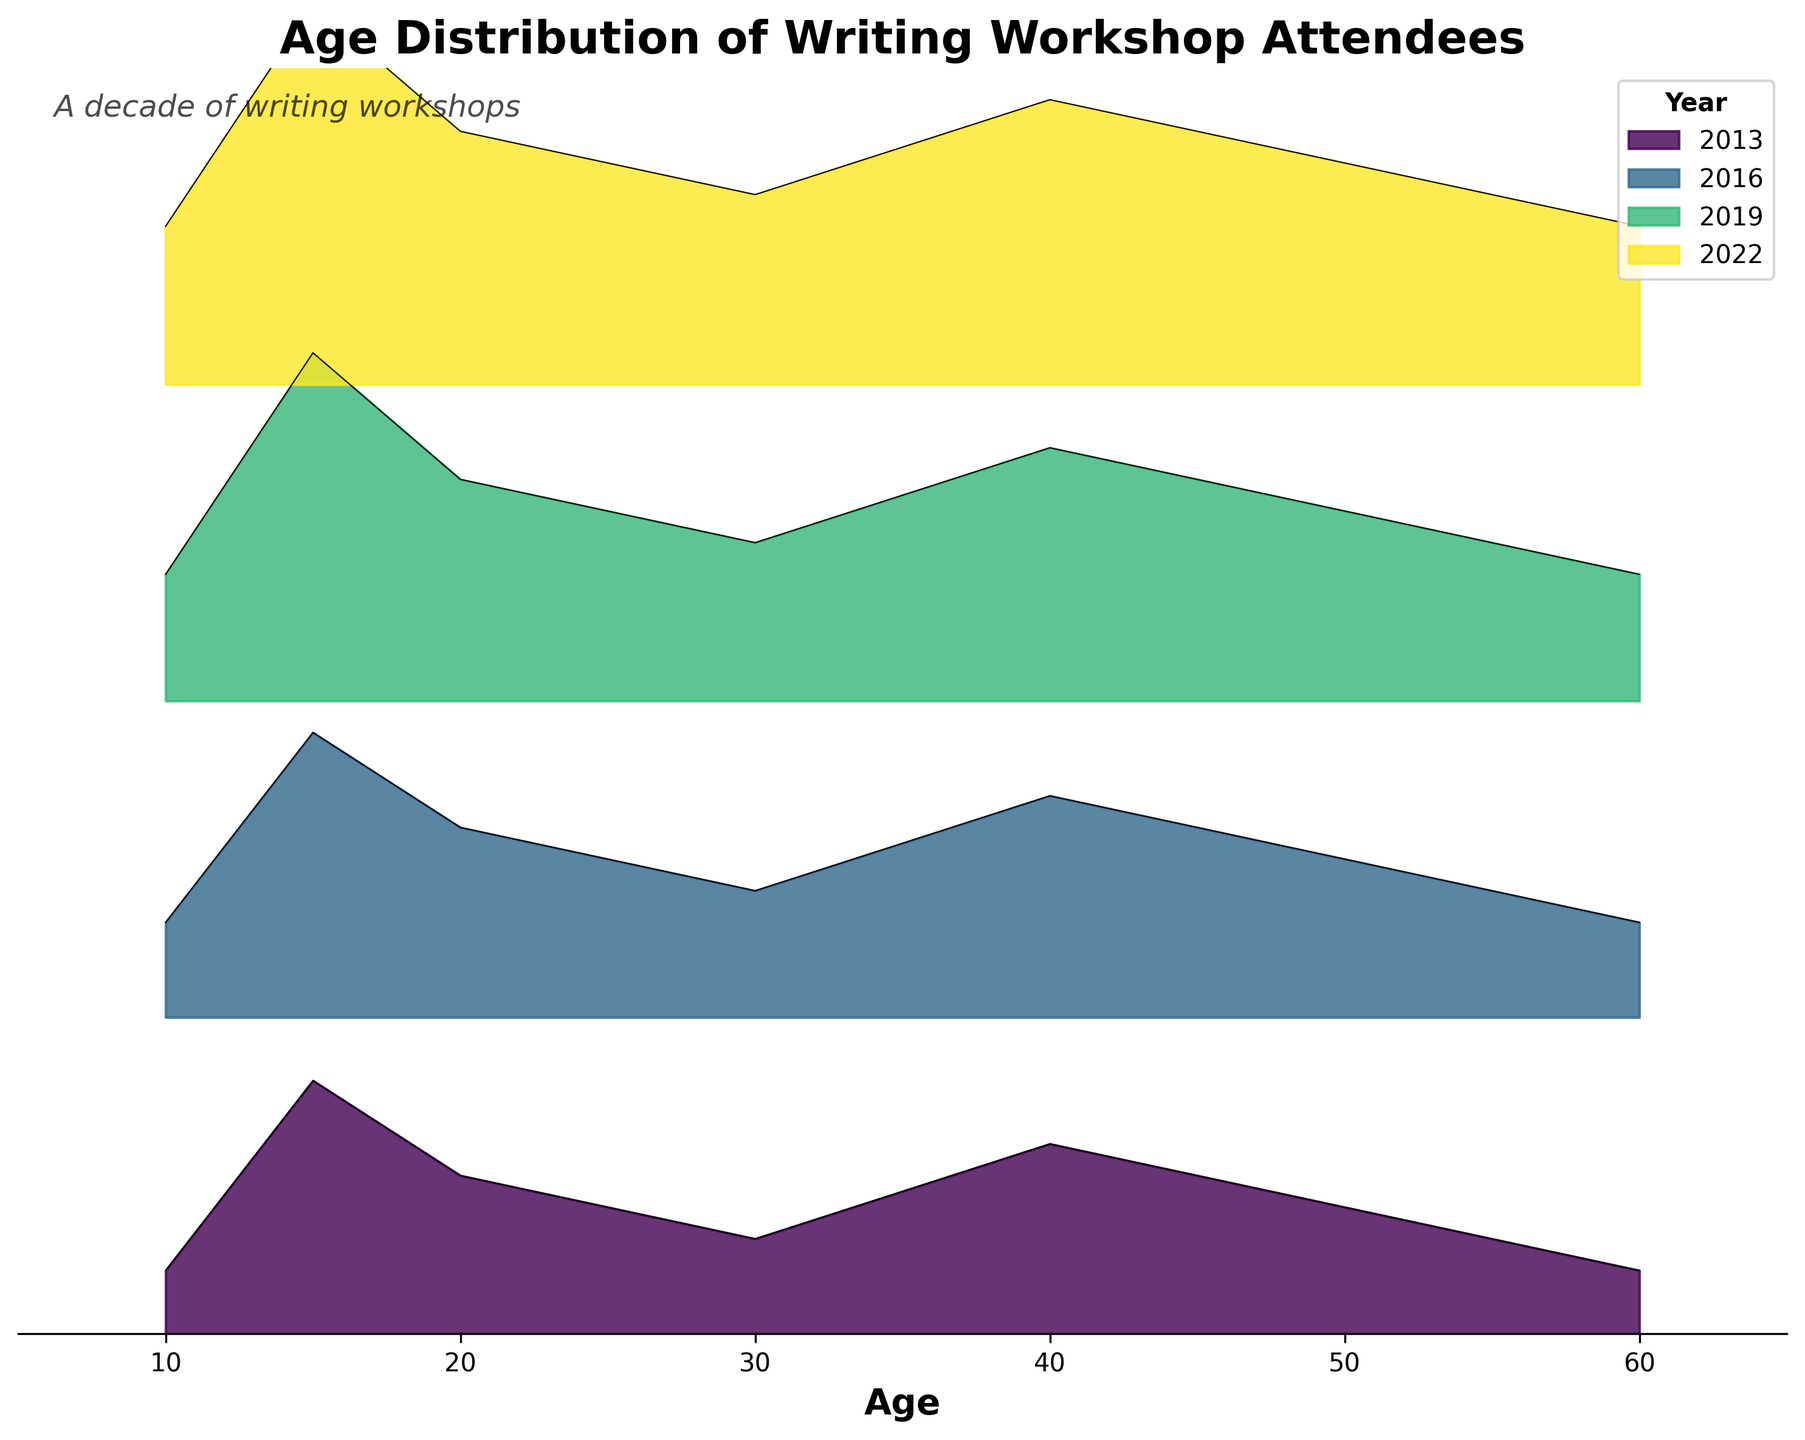What's the title of the figure? The title of the figure is typically found at the top and is used to summarize the content. It includes a few concise words.
Answer: Age Distribution of Writing Workshop Attendees What are the x-axis labels? The x-axis labels usually indicate the variable being measured. In this case, look for labels along the horizontal axis.
Answer: Age How many different years are shown in the plot? The years can be deduced from the legend or by counting distinct sections with different colors.
Answer: 4 In 2022, which age group had the highest density of attendees? Look at the outline of the density curve for 2022 and find the peak value and corresponding age.
Answer: 15 years How does the density of attendees aged 20 in 2019 compare to those aged 20 in 2022? Locate the densities for age 20 in both 2019 and 2022, then compare them.
Answer: Density in 2022 is higher Did the age group of 50-year-olds see an increase or decrease in density from 2013 to 2022? Look at the density values for age 50 in both 2013 and 2022, compare the heights of the respective curves.
Answer: Increase Which year had the least dense participation among 15-year-olds? Find the densities for age 15 in each year, then identify the lowest one.
Answer: 2013 What is the trend for the density of 10-year-old attendees over the years? Observe the curve densities for the age 10 over all years investigated in the plot and describe the pattern.
Answer: Increasing Between 2013 and 2019, which age group (10, 15, 20, etc.) showed the most significant increase in density? Compare the densities for each age group between 2013 and 2019 and note which had the largest difference.
Answer: 15 years 